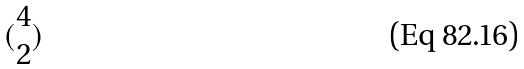<formula> <loc_0><loc_0><loc_500><loc_500>( \begin{matrix} 4 \\ 2 \end{matrix} )</formula> 